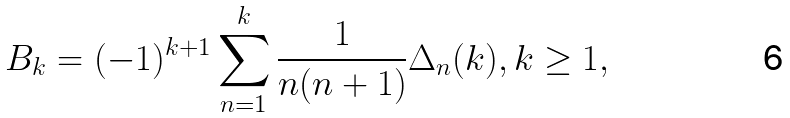Convert formula to latex. <formula><loc_0><loc_0><loc_500><loc_500>B _ { k } = ( - 1 ) ^ { k + 1 } \sum _ { n = 1 } ^ { k } \frac { 1 } { n ( n + 1 ) } \Delta _ { n } ( k ) , k \geq 1 ,</formula> 